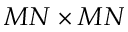<formula> <loc_0><loc_0><loc_500><loc_500>M N \times M N</formula> 